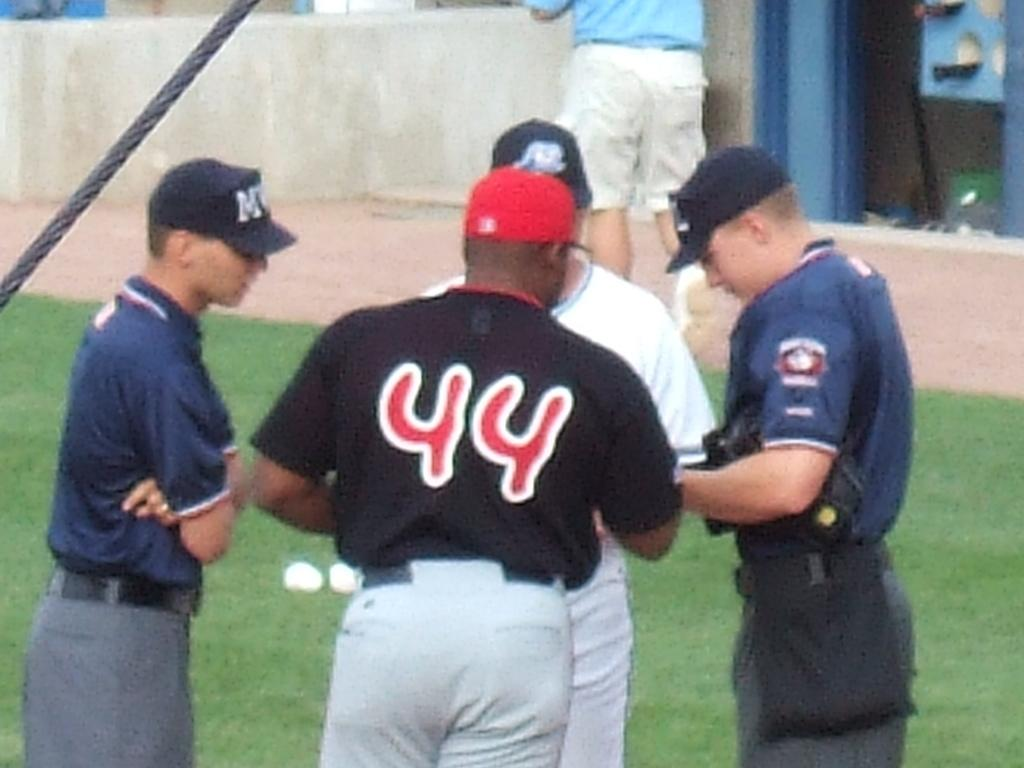<image>
Share a concise interpretation of the image provided. Player 44 is wearing a red hat and talking to some other people. 